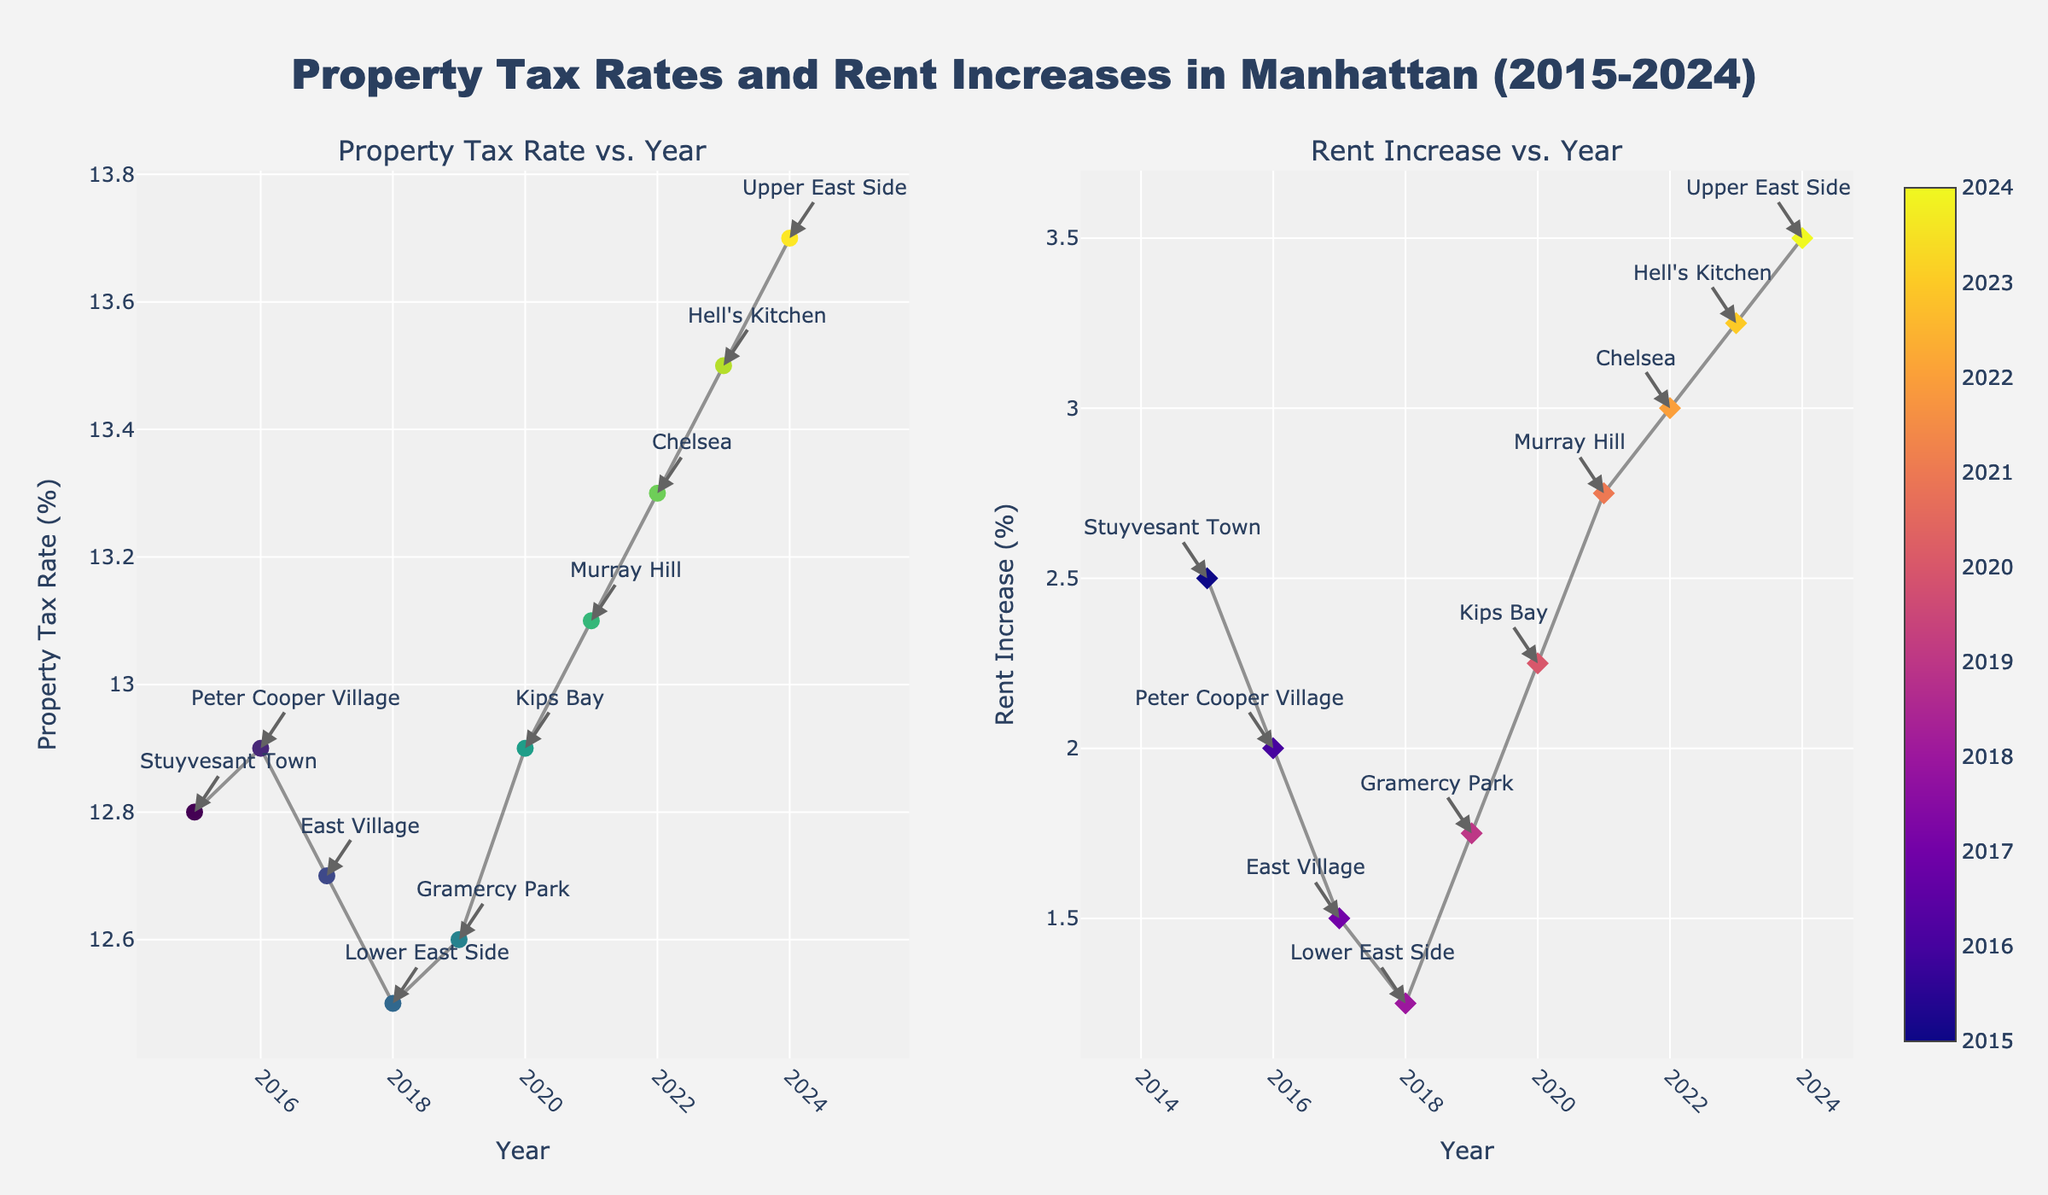In which year was the Property Tax Rate highest? Look at the left subplot indicating 'Property Tax Rate vs. Year', identify the highest point on the y-axis, which is in 2024 at around 13.7%.
Answer: 2024 Which neighborhood had the highest Rent Increase? The right subplot 'Rent Increase vs. Year' shows data points for different neighborhoods. Notice that the highest point on the y-axis is for Hell's Kitchen in 2023 with a Rent Increase of 3.25%.
Answer: Hell's Kitchen What's the title of the figure? The title of the figure is displayed at the top center of the figure. It reads 'Property Tax Rates and Rent Increases in Manhattan (2015-2024)'.
Answer: Property Tax Rates and Rent Increases in Manhattan (2015-2024) How did the Rent Increase change from 2017 to 2018? Observe the right subplot and locate the data points for 2017 and 2018. Compare the y-axis values; it decreased from 1.5% in 2017 to 1.25% in 2018.
Answer: Decreased Which year had the lowest Rent Increase? On the right subplot 'Rent Increase vs. Year', identify the lowest point on the y-axis which is in 2018 with a Rent Increase of 1.25%.
Answer: 2018 Compare the Property Tax Rates in 2020 and 2021. Which year was higher? In the left subplot, find the data points for 2020 and 2021. The Property Tax Rate increased from 12.9% in 2020 to 13.1% in 2021. Hence, 2021 had a higher Property Tax Rate.
Answer: 2021 Identify the neighborhood with a Property Tax Rate of 12.9% and its corresponding Rent Increase. Look for data points in the left subplot with a Property Tax Rate of 12.9%. In both 2016 and 2020, the neighborhoods are Peter Cooper Village and Kips Bay, respectively. For Peter Cooper Village (2016) the Rent Increase is 2.0% and for Kips Bay (2020), it's 2.25%.
Answer: Peter Cooper Village: 2.0%, Kips Bay: 2.25% How does the property tax rate trend from 2015 to 2024? Look at the left subplot 'Property Tax Rate vs. Year'. Notice a general upward trend in the Property Tax Rate from 12.8% in 2015 to 13.7% in 2024.
Answer: Upward trend What is the average Rent Increase over the period 2015 to 2024? Add the Rent Increase values from 2015 to 2024: 2.5 + 2.0 + 1.5 + 1.25 + 1.75 + 2.25 + 2.75 + 3.0 + 3.25 + 3.5 = 23.75. Divide by 10 years: 23.75 / 10 = 2.375
Answer: 2.375% Which neighborhood had the highest Property Tax Rate, and what was its corresponding Rent Increase? Check the left subplot for the highest Property Tax Rate, which is Upper East Side in 2024 at 13.7%. The corresponding Rent Increase can be found in the right subplot, which is 3.5%.
Answer: Upper East Side: 3.5% 